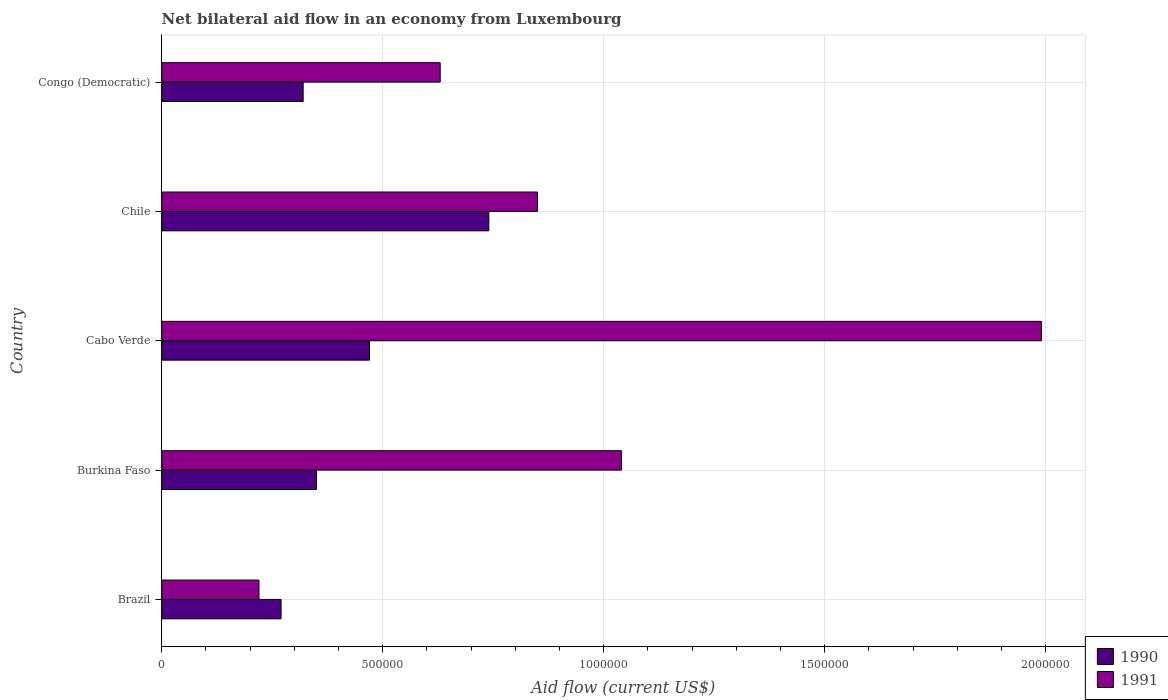Are the number of bars on each tick of the Y-axis equal?
Offer a very short reply. Yes. How many bars are there on the 3rd tick from the bottom?
Keep it short and to the point. 2. What is the label of the 5th group of bars from the top?
Your answer should be compact. Brazil. In how many cases, is the number of bars for a given country not equal to the number of legend labels?
Ensure brevity in your answer.  0. What is the net bilateral aid flow in 1991 in Burkina Faso?
Keep it short and to the point. 1.04e+06. Across all countries, what is the maximum net bilateral aid flow in 1991?
Your response must be concise. 1.99e+06. Across all countries, what is the minimum net bilateral aid flow in 1991?
Provide a succinct answer. 2.20e+05. In which country was the net bilateral aid flow in 1991 minimum?
Your answer should be very brief. Brazil. What is the total net bilateral aid flow in 1991 in the graph?
Your response must be concise. 4.73e+06. What is the difference between the net bilateral aid flow in 1991 in Cabo Verde and that in Congo (Democratic)?
Your answer should be compact. 1.36e+06. What is the difference between the net bilateral aid flow in 1990 in Chile and the net bilateral aid flow in 1991 in Cabo Verde?
Keep it short and to the point. -1.25e+06. What is the average net bilateral aid flow in 1990 per country?
Your answer should be compact. 4.30e+05. What is the difference between the net bilateral aid flow in 1991 and net bilateral aid flow in 1990 in Cabo Verde?
Ensure brevity in your answer.  1.52e+06. In how many countries, is the net bilateral aid flow in 1990 greater than 1600000 US$?
Make the answer very short. 0. What is the ratio of the net bilateral aid flow in 1990 in Burkina Faso to that in Congo (Democratic)?
Make the answer very short. 1.09. Is the net bilateral aid flow in 1991 in Brazil less than that in Burkina Faso?
Provide a succinct answer. Yes. Is the difference between the net bilateral aid flow in 1991 in Chile and Congo (Democratic) greater than the difference between the net bilateral aid flow in 1990 in Chile and Congo (Democratic)?
Provide a short and direct response. No. What is the difference between the highest and the second highest net bilateral aid flow in 1991?
Give a very brief answer. 9.50e+05. What is the difference between the highest and the lowest net bilateral aid flow in 1991?
Your answer should be compact. 1.77e+06. Is the sum of the net bilateral aid flow in 1990 in Brazil and Burkina Faso greater than the maximum net bilateral aid flow in 1991 across all countries?
Keep it short and to the point. No. What does the 1st bar from the top in Chile represents?
Provide a short and direct response. 1991. What does the 1st bar from the bottom in Congo (Democratic) represents?
Ensure brevity in your answer.  1990. Are all the bars in the graph horizontal?
Ensure brevity in your answer.  Yes. Does the graph contain any zero values?
Your answer should be very brief. No. How many legend labels are there?
Make the answer very short. 2. How are the legend labels stacked?
Make the answer very short. Vertical. What is the title of the graph?
Provide a succinct answer. Net bilateral aid flow in an economy from Luxembourg. What is the label or title of the X-axis?
Your response must be concise. Aid flow (current US$). What is the label or title of the Y-axis?
Provide a succinct answer. Country. What is the Aid flow (current US$) of 1990 in Brazil?
Provide a short and direct response. 2.70e+05. What is the Aid flow (current US$) of 1990 in Burkina Faso?
Ensure brevity in your answer.  3.50e+05. What is the Aid flow (current US$) of 1991 in Burkina Faso?
Give a very brief answer. 1.04e+06. What is the Aid flow (current US$) of 1991 in Cabo Verde?
Keep it short and to the point. 1.99e+06. What is the Aid flow (current US$) of 1990 in Chile?
Keep it short and to the point. 7.40e+05. What is the Aid flow (current US$) of 1991 in Chile?
Your response must be concise. 8.50e+05. What is the Aid flow (current US$) of 1991 in Congo (Democratic)?
Your answer should be very brief. 6.30e+05. Across all countries, what is the maximum Aid flow (current US$) of 1990?
Offer a terse response. 7.40e+05. Across all countries, what is the maximum Aid flow (current US$) in 1991?
Your answer should be compact. 1.99e+06. Across all countries, what is the minimum Aid flow (current US$) of 1990?
Your answer should be very brief. 2.70e+05. What is the total Aid flow (current US$) in 1990 in the graph?
Offer a terse response. 2.15e+06. What is the total Aid flow (current US$) of 1991 in the graph?
Keep it short and to the point. 4.73e+06. What is the difference between the Aid flow (current US$) of 1991 in Brazil and that in Burkina Faso?
Keep it short and to the point. -8.20e+05. What is the difference between the Aid flow (current US$) of 1990 in Brazil and that in Cabo Verde?
Your answer should be very brief. -2.00e+05. What is the difference between the Aid flow (current US$) of 1991 in Brazil and that in Cabo Verde?
Your answer should be compact. -1.77e+06. What is the difference between the Aid flow (current US$) of 1990 in Brazil and that in Chile?
Keep it short and to the point. -4.70e+05. What is the difference between the Aid flow (current US$) in 1991 in Brazil and that in Chile?
Your response must be concise. -6.30e+05. What is the difference between the Aid flow (current US$) of 1990 in Brazil and that in Congo (Democratic)?
Your answer should be very brief. -5.00e+04. What is the difference between the Aid flow (current US$) of 1991 in Brazil and that in Congo (Democratic)?
Provide a short and direct response. -4.10e+05. What is the difference between the Aid flow (current US$) of 1991 in Burkina Faso and that in Cabo Verde?
Offer a terse response. -9.50e+05. What is the difference between the Aid flow (current US$) of 1990 in Burkina Faso and that in Chile?
Offer a terse response. -3.90e+05. What is the difference between the Aid flow (current US$) in 1990 in Burkina Faso and that in Congo (Democratic)?
Keep it short and to the point. 3.00e+04. What is the difference between the Aid flow (current US$) of 1991 in Burkina Faso and that in Congo (Democratic)?
Offer a very short reply. 4.10e+05. What is the difference between the Aid flow (current US$) of 1991 in Cabo Verde and that in Chile?
Make the answer very short. 1.14e+06. What is the difference between the Aid flow (current US$) in 1990 in Cabo Verde and that in Congo (Democratic)?
Make the answer very short. 1.50e+05. What is the difference between the Aid flow (current US$) in 1991 in Cabo Verde and that in Congo (Democratic)?
Offer a very short reply. 1.36e+06. What is the difference between the Aid flow (current US$) of 1990 in Chile and that in Congo (Democratic)?
Ensure brevity in your answer.  4.20e+05. What is the difference between the Aid flow (current US$) of 1991 in Chile and that in Congo (Democratic)?
Provide a short and direct response. 2.20e+05. What is the difference between the Aid flow (current US$) of 1990 in Brazil and the Aid flow (current US$) of 1991 in Burkina Faso?
Make the answer very short. -7.70e+05. What is the difference between the Aid flow (current US$) of 1990 in Brazil and the Aid flow (current US$) of 1991 in Cabo Verde?
Your answer should be compact. -1.72e+06. What is the difference between the Aid flow (current US$) of 1990 in Brazil and the Aid flow (current US$) of 1991 in Chile?
Offer a very short reply. -5.80e+05. What is the difference between the Aid flow (current US$) of 1990 in Brazil and the Aid flow (current US$) of 1991 in Congo (Democratic)?
Provide a succinct answer. -3.60e+05. What is the difference between the Aid flow (current US$) of 1990 in Burkina Faso and the Aid flow (current US$) of 1991 in Cabo Verde?
Provide a succinct answer. -1.64e+06. What is the difference between the Aid flow (current US$) of 1990 in Burkina Faso and the Aid flow (current US$) of 1991 in Chile?
Your answer should be very brief. -5.00e+05. What is the difference between the Aid flow (current US$) in 1990 in Burkina Faso and the Aid flow (current US$) in 1991 in Congo (Democratic)?
Offer a terse response. -2.80e+05. What is the difference between the Aid flow (current US$) in 1990 in Cabo Verde and the Aid flow (current US$) in 1991 in Chile?
Offer a very short reply. -3.80e+05. What is the difference between the Aid flow (current US$) in 1990 in Cabo Verde and the Aid flow (current US$) in 1991 in Congo (Democratic)?
Provide a succinct answer. -1.60e+05. What is the difference between the Aid flow (current US$) of 1990 in Chile and the Aid flow (current US$) of 1991 in Congo (Democratic)?
Your answer should be very brief. 1.10e+05. What is the average Aid flow (current US$) of 1991 per country?
Your answer should be compact. 9.46e+05. What is the difference between the Aid flow (current US$) of 1990 and Aid flow (current US$) of 1991 in Burkina Faso?
Give a very brief answer. -6.90e+05. What is the difference between the Aid flow (current US$) in 1990 and Aid flow (current US$) in 1991 in Cabo Verde?
Make the answer very short. -1.52e+06. What is the difference between the Aid flow (current US$) of 1990 and Aid flow (current US$) of 1991 in Congo (Democratic)?
Your answer should be compact. -3.10e+05. What is the ratio of the Aid flow (current US$) of 1990 in Brazil to that in Burkina Faso?
Keep it short and to the point. 0.77. What is the ratio of the Aid flow (current US$) of 1991 in Brazil to that in Burkina Faso?
Your answer should be compact. 0.21. What is the ratio of the Aid flow (current US$) in 1990 in Brazil to that in Cabo Verde?
Your response must be concise. 0.57. What is the ratio of the Aid flow (current US$) of 1991 in Brazil to that in Cabo Verde?
Your response must be concise. 0.11. What is the ratio of the Aid flow (current US$) in 1990 in Brazil to that in Chile?
Keep it short and to the point. 0.36. What is the ratio of the Aid flow (current US$) in 1991 in Brazil to that in Chile?
Your answer should be very brief. 0.26. What is the ratio of the Aid flow (current US$) in 1990 in Brazil to that in Congo (Democratic)?
Provide a short and direct response. 0.84. What is the ratio of the Aid flow (current US$) in 1991 in Brazil to that in Congo (Democratic)?
Make the answer very short. 0.35. What is the ratio of the Aid flow (current US$) of 1990 in Burkina Faso to that in Cabo Verde?
Your response must be concise. 0.74. What is the ratio of the Aid flow (current US$) of 1991 in Burkina Faso to that in Cabo Verde?
Offer a terse response. 0.52. What is the ratio of the Aid flow (current US$) of 1990 in Burkina Faso to that in Chile?
Provide a short and direct response. 0.47. What is the ratio of the Aid flow (current US$) in 1991 in Burkina Faso to that in Chile?
Provide a short and direct response. 1.22. What is the ratio of the Aid flow (current US$) of 1990 in Burkina Faso to that in Congo (Democratic)?
Your answer should be very brief. 1.09. What is the ratio of the Aid flow (current US$) of 1991 in Burkina Faso to that in Congo (Democratic)?
Make the answer very short. 1.65. What is the ratio of the Aid flow (current US$) of 1990 in Cabo Verde to that in Chile?
Offer a terse response. 0.64. What is the ratio of the Aid flow (current US$) in 1991 in Cabo Verde to that in Chile?
Keep it short and to the point. 2.34. What is the ratio of the Aid flow (current US$) in 1990 in Cabo Verde to that in Congo (Democratic)?
Provide a short and direct response. 1.47. What is the ratio of the Aid flow (current US$) in 1991 in Cabo Verde to that in Congo (Democratic)?
Give a very brief answer. 3.16. What is the ratio of the Aid flow (current US$) in 1990 in Chile to that in Congo (Democratic)?
Your response must be concise. 2.31. What is the ratio of the Aid flow (current US$) in 1991 in Chile to that in Congo (Democratic)?
Give a very brief answer. 1.35. What is the difference between the highest and the second highest Aid flow (current US$) in 1991?
Give a very brief answer. 9.50e+05. What is the difference between the highest and the lowest Aid flow (current US$) in 1991?
Provide a succinct answer. 1.77e+06. 